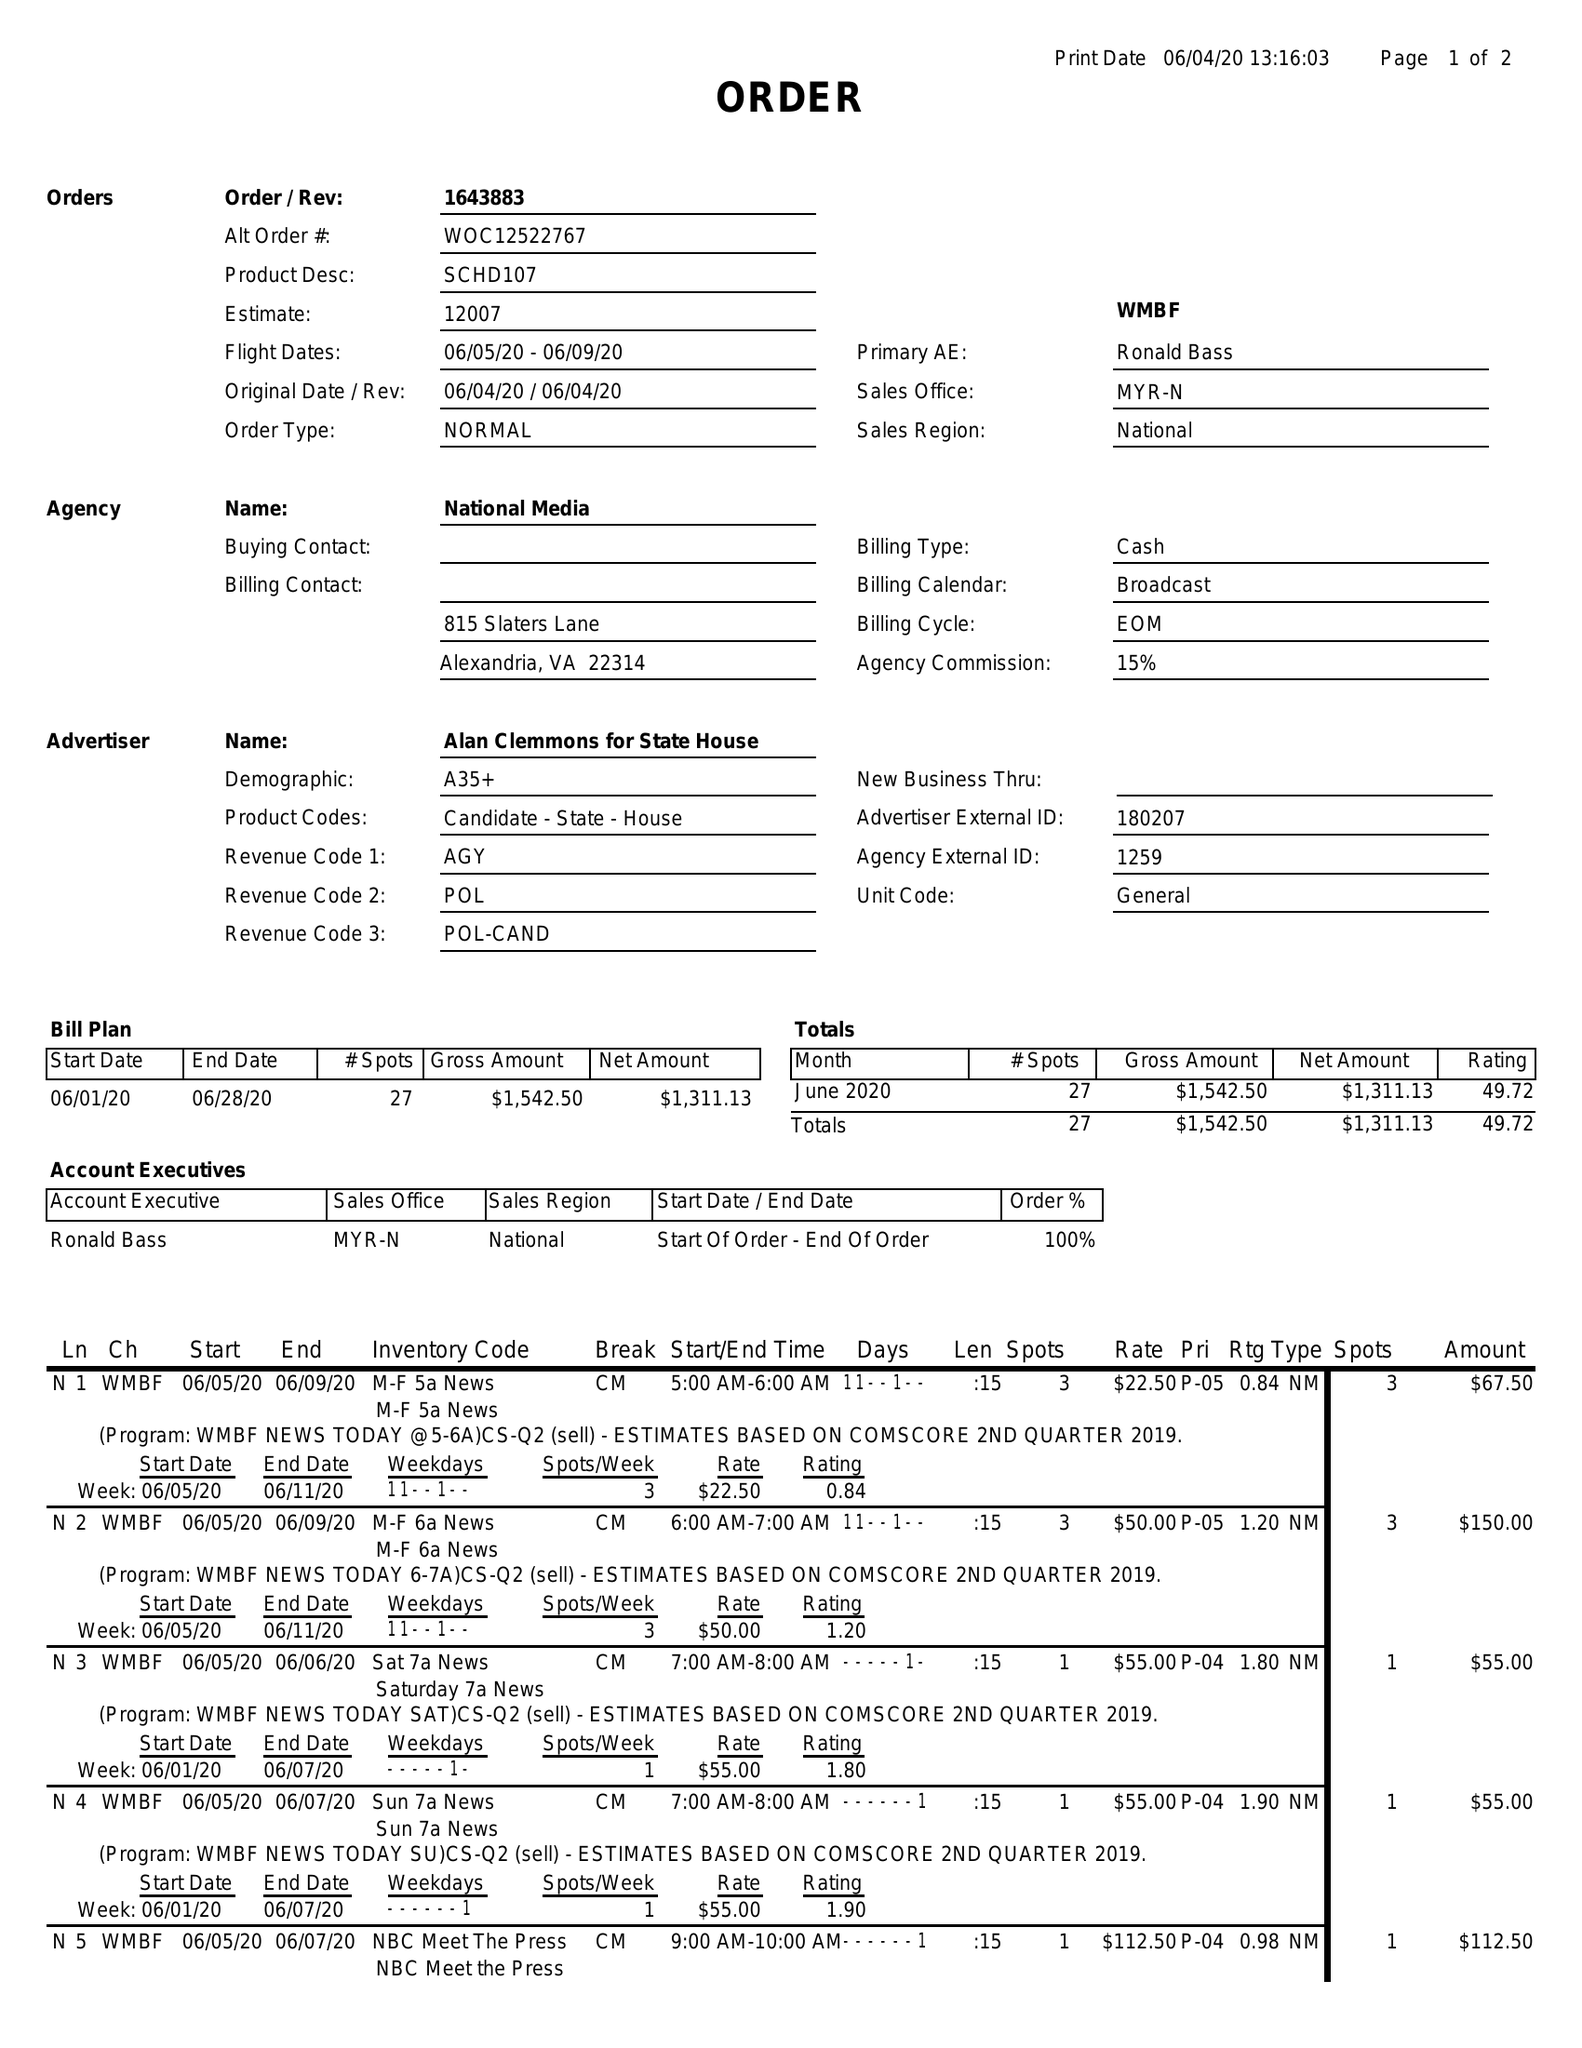What is the value for the flight_from?
Answer the question using a single word or phrase. 06/05/20 